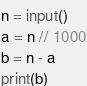<code> <loc_0><loc_0><loc_500><loc_500><_Python_>n = input()
a = n // 1000
b = n - a
print(b)</code> 